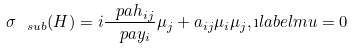Convert formula to latex. <formula><loc_0><loc_0><loc_500><loc_500>\sigma _ { \ s u b } ( H ) = i \frac { \ p a h _ { i j } } { \ p a y _ { i } } \mu _ { j } + a _ { i j } \mu _ { i } \mu _ { j } , \i l a b e l { m u = 0 }</formula> 